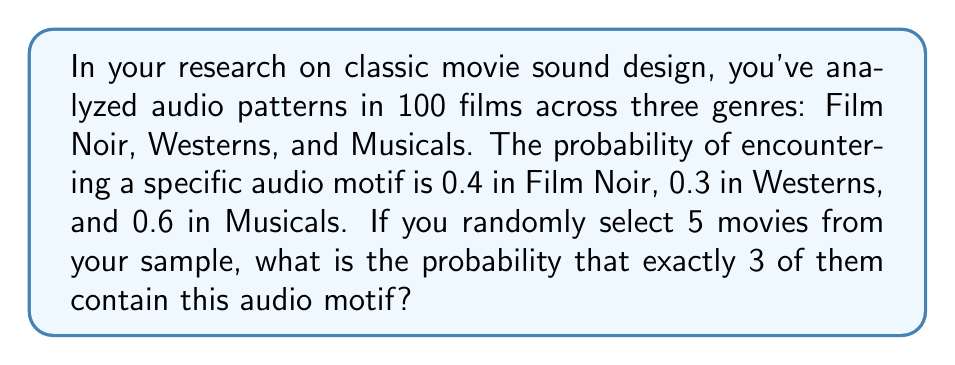Could you help me with this problem? Let's approach this step-by-step using the binomial probability formula:

1) First, we need to calculate the overall probability of encountering the audio motif in any randomly selected movie from the sample:

   $P(\text{motif}) = \frac{40 + 30 + 60}{100} = \frac{130}{100} = 0.65$

2) Now, we can use the binomial probability formula:

   $P(X = k) = \binom{n}{k} p^k (1-p)^{n-k}$

   Where:
   $n = 5$ (total number of movies selected)
   $k = 3$ (number of successes we're looking for)
   $p = 0.65$ (probability of success on each trial)

3) Let's calculate each part:

   $\binom{5}{3} = \frac{5!}{3!(5-3)!} = 10$

   $p^k = 0.65^3 \approx 0.274625$

   $(1-p)^{n-k} = (1-0.65)^{5-3} = 0.35^2 = 0.1225$

4) Now, let's put it all together:

   $P(X = 3) = 10 \times 0.274625 \times 0.1225 \approx 0.3364$

Therefore, the probability of exactly 3 out of 5 randomly selected movies containing the audio motif is approximately 0.3364 or 33.64%.
Answer: $\approx 0.3364$ 